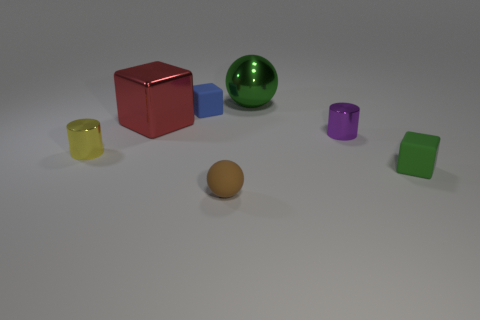There is a small cube in front of the big red metallic object; does it have the same color as the metallic sphere?
Your answer should be compact. Yes. The yellow thing that is made of the same material as the big red object is what shape?
Your answer should be very brief. Cylinder. There is a block that is to the right of the red object and on the left side of the tiny purple object; what is its color?
Your answer should be very brief. Blue. How big is the green object that is behind the large shiny thing in front of the large green sphere?
Provide a succinct answer. Large. Is there a matte object that has the same color as the metal ball?
Your answer should be compact. Yes. Is the number of green objects to the left of the tiny brown ball the same as the number of purple metal cylinders?
Your response must be concise. No. What number of small brown metallic objects are there?
Offer a terse response. 0. What is the shape of the object that is both left of the big green metallic thing and behind the big red metal thing?
Make the answer very short. Cube. There is a tiny matte block behind the yellow cylinder; is it the same color as the metal cylinder that is left of the big green metallic sphere?
Your response must be concise. No. The thing that is the same color as the big metallic sphere is what size?
Provide a succinct answer. Small. 